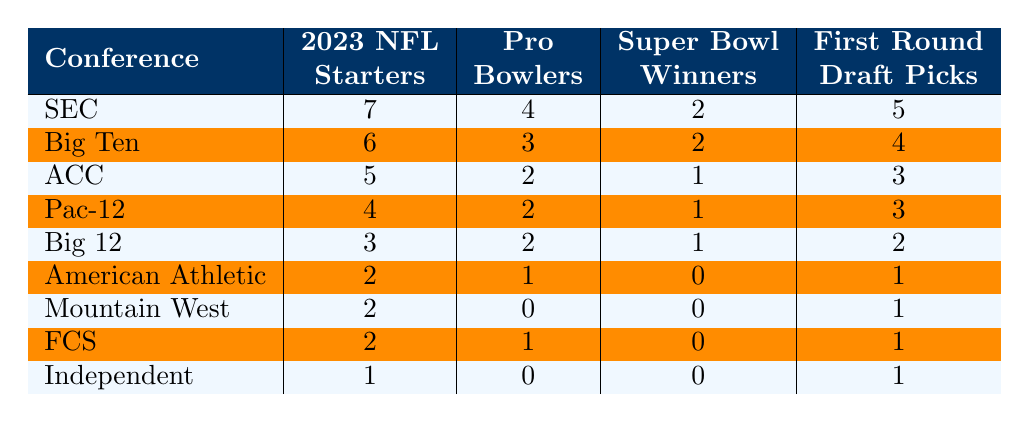What conference has the highest number of 2023 NFL starters? By looking at the table, the SEC has 7 starters, which is more than any other conference listed.
Answer: SEC How many Pro Bowlers are from the Big Ten? The table shows that the Big Ten has 3 Pro Bowlers.
Answer: 3 Which conference has the least number of Super Bowl winners? The American Athletic, Mountain West, FCS, and Independent all have 0 Super Bowl winners, which is the least among the listed conferences.
Answer: American Athletic, Mountain West, FCS, Independent What is the total number of First Round Draft Picks from the SEC and Big Ten combined? The SEC has 5 First Round Draft Picks and the Big Ten has 4. Combining these gives 5 + 4 = 9 First Round Draft Picks.
Answer: 9 How many total NFL starters are there from the ACC and Pac-12? The ACC has 5 starters and the Pac-12 has 4 starters, so the total is 5 + 4 = 9.
Answer: 9 Is it true that the Big 12 has more Pro Bowlers than the ACC? The Big 12 has 2 Pro Bowlers while the ACC has 2 as well, so they are equal. Therefore, it is false that the Big 12 has more.
Answer: No Which conference has more NFL starters, the Mountain West or the American Athletic Conference? The Mountain West has 2 starters, while the American Athletic has 2 starters as well. They are equal.
Answer: Equal What percentage of NFL starters from the SEC are Pro Bowlers? The SEC has 7 starters and 4 are Pro Bowlers. To find the percentage: (4/7) * 100 ≈ 57.14%.
Answer: Approximately 57.14% If we consider all conferences together, how many First Round Draft Picks are there in total? Adding the First Round Draft Picks from all conferences: 5 + 4 + 3 + 3 + 2 + 1 + 1 + 1 + 1 = 21.
Answer: 21 Which conference has the same number of Super Bowl winners as the American Athletic? Both the Big 12 and the Mountain West have 1 Super Bowl winner, which is the same as the American Athletic.
Answer: Big 12, Mountain West 